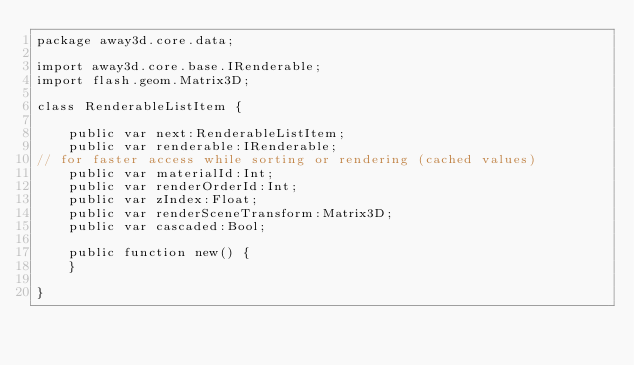Convert code to text. <code><loc_0><loc_0><loc_500><loc_500><_Haxe_>package away3d.core.data;

import away3d.core.base.IRenderable;
import flash.geom.Matrix3D;

class RenderableListItem {

    public var next:RenderableListItem;
    public var renderable:IRenderable;
// for faster access while sorting or rendering (cached values)
    public var materialId:Int;
    public var renderOrderId:Int;
    public var zIndex:Float;
    public var renderSceneTransform:Matrix3D;
    public var cascaded:Bool;

    public function new() {
    }

}

</code> 